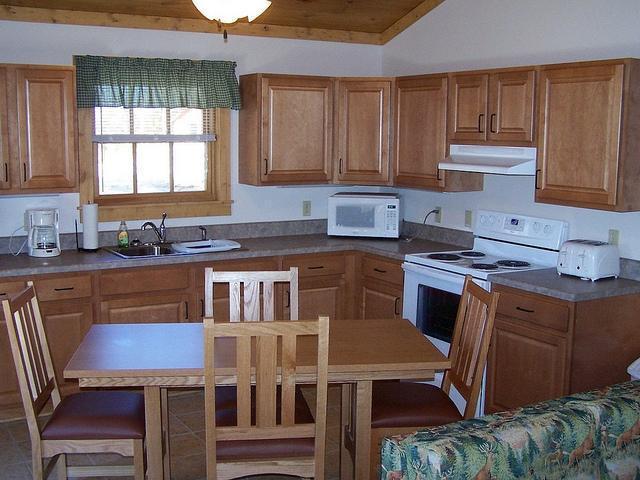How many people can site at a time here?
Give a very brief answer. 4. How many ovens can you see?
Give a very brief answer. 1. How many chairs are there?
Give a very brief answer. 4. How many people are wearing pink coats?
Give a very brief answer. 0. 